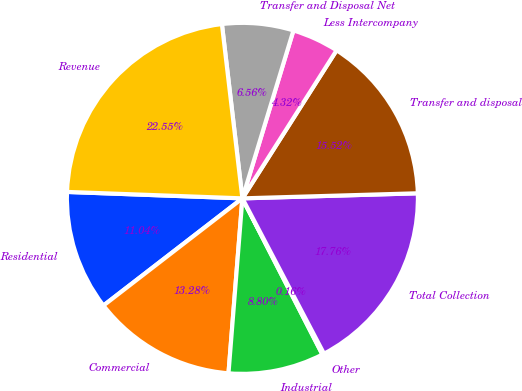<chart> <loc_0><loc_0><loc_500><loc_500><pie_chart><fcel>Residential<fcel>Commercial<fcel>Industrial<fcel>Other<fcel>Total Collection<fcel>Transfer and disposal<fcel>Less Intercompany<fcel>Transfer and Disposal Net<fcel>Revenue<nl><fcel>11.04%<fcel>13.28%<fcel>8.8%<fcel>0.16%<fcel>17.76%<fcel>15.52%<fcel>4.32%<fcel>6.56%<fcel>22.55%<nl></chart> 